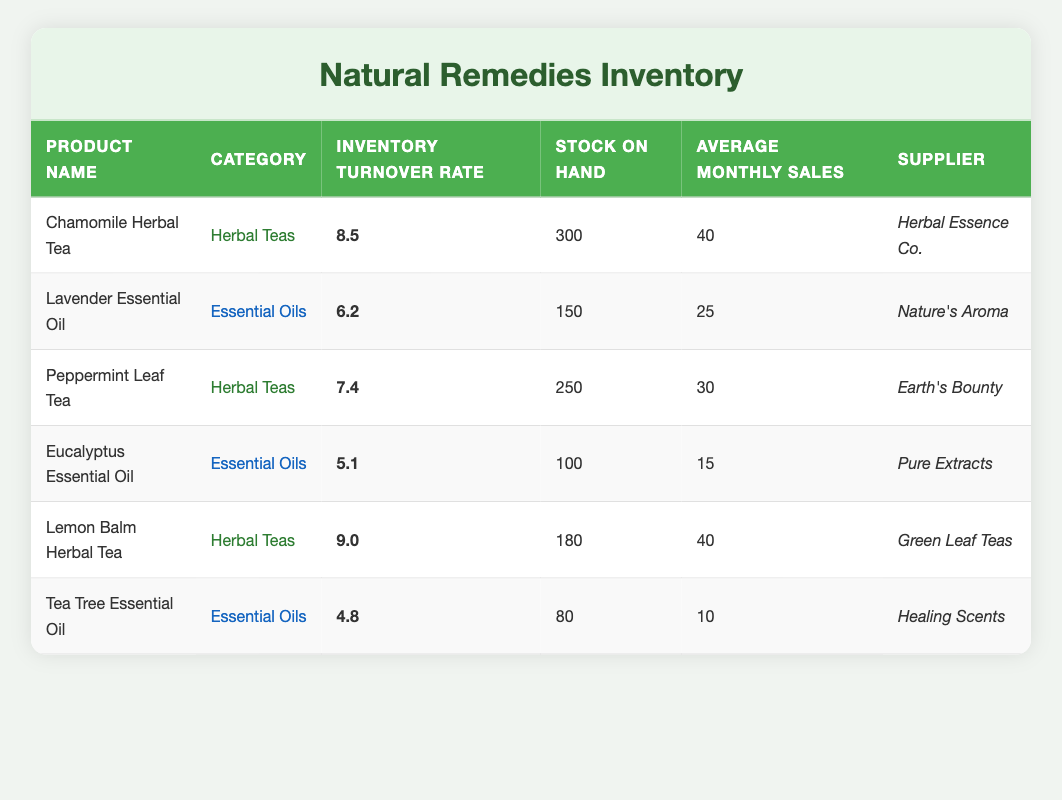What is the inventory turnover rate for Chamomile Herbal Tea? The table lists Chamomile Herbal Tea and shows its inventory turnover rate as 8.5.
Answer: 8.5 Which product has the highest inventory turnover rate? By examining the inventory turnover rates, Lemon Balm Herbal Tea has a rate of 9.0, which is higher than any other product listed.
Answer: Lemon Balm Herbal Tea How many units of stock on hand does Eucalyptus Essential Oil have? The table indicates that Eucalyptus Essential Oil has 100 units of stock on hand.
Answer: 100 What is the average monthly sales for Lavender Essential Oil? The table states that the average monthly sales for Lavender Essential Oil are 25 units.
Answer: 25 Is Tea Tree Essential Oil stocked in more than 80 units? The table shows that Tea Tree Essential Oil has only 80 units in stock. Therefore, it is not stocked in more than that amount.
Answer: No What is the total number of herbal teas in stock? From the table, Chamomile Herbal Tea has 300 units, Peppermint Leaf Tea has 250 units, and Lemon Balm Herbal Tea has 180 units. Adding these amounts gives 300 + 250 + 180 = 730 units in total.
Answer: 730 Which category has the lower average inventory turnover rate: Herbal Teas or Essential Oils? The turnover rates for Herbal Teas are 8.5, 7.4, and 9.0, giving an average of (8.5 + 7.4 + 9.0) / 3 = 8.33. For Essential Oils, the rates are 6.2, 5.1, and 4.8, giving an average of (6.2 + 5.1 + 4.8) / 3 = 5.37. Since 5.37 < 8.33, Essential Oils have the lower average turnover rate.
Answer: Essential Oils What is the difference in inventory turnover rate between the highest and the lowest? The highest turnover rate is 9.0 for Lemon Balm Herbal Tea, and the lowest is 4.8 for Tea Tree Essential Oil. The difference is calculated by subtracting: 9.0 - 4.8 = 4.2.
Answer: 4.2 Are there more units of Peppermint Leaf Tea in stock than Lavender Essential Oil? The table shows Peppermint Leaf Tea has 250 units, while Lavender Essential Oil has 150 units. Since 250 > 150, Peppermint Leaf Tea has more units in stock.
Answer: Yes 